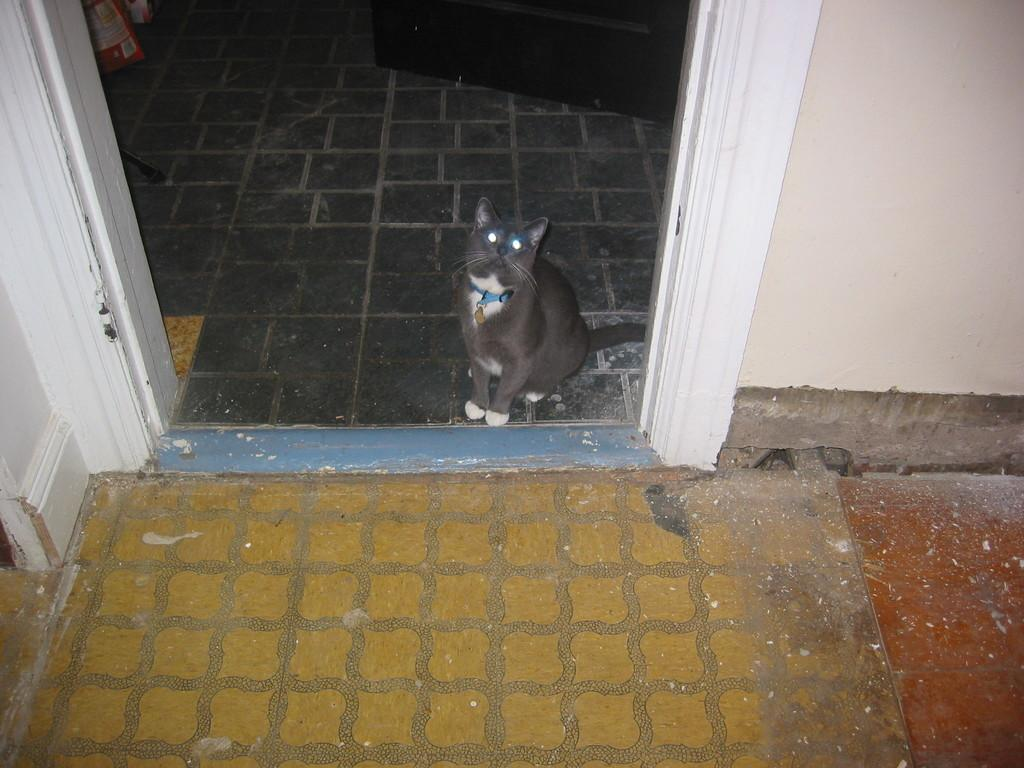What type of animal is in the picture? There is a cat in the picture. What is located behind the cat? There is a wall in the picture. What can be seen in the distance behind the cat and the wall? There are objects visible in the background of the picture. What type of insurance policy does the cat have in the picture? There is no information about the cat's insurance policy in the picture. What punishment is the cat receiving in the picture? There is no indication of any punishment being given to the cat in the picture. 